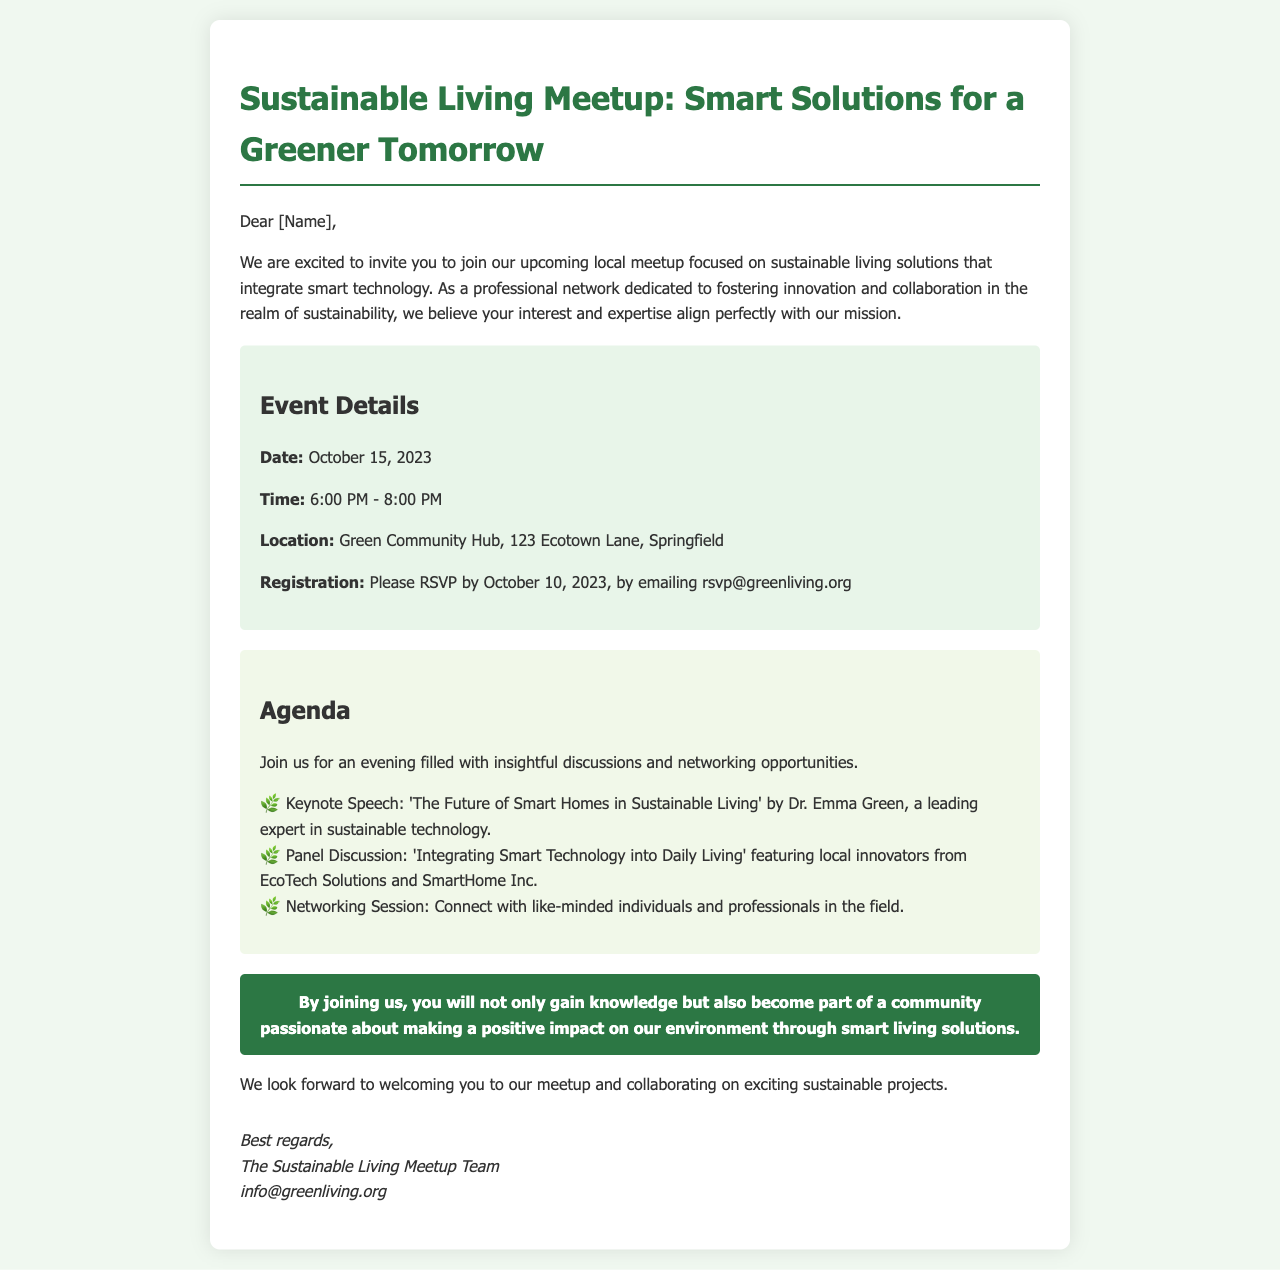What is the date of the event? The event date is explicitly stated in the document under "Event Details."
Answer: October 15, 2023 What time does the meetup start? The starting time is mentioned in the "Event Details" section of the document.
Answer: 6:00 PM Where is the event located? The location of the meetup is provided in the "Event Details" section.
Answer: Green Community Hub, 123 Ecotown Lane, Springfield Who is the keynote speaker? The document specifies the keynote speaker in the agenda section.
Answer: Dr. Emma Green What topic will the keynote speech cover? The topic of the keynote speech is included in the agenda.
Answer: The Future of Smart Homes in Sustainable Living When is the RSVP deadline? The RSVP deadline is mentioned in the "Event Details" section.
Answer: October 10, 2023 What is the purpose of the networking session? The purpose of the networking session is described in the agenda section.
Answer: Connect with like-minded individuals and professionals What type of organization is the meetup affiliated with? The type of organization is indicated at the beginning of the letter.
Answer: Professional network How can one RSVP for the event? The method for RSVPing is clearly outlined in the "Event Details" section.
Answer: By emailing rsvp@greenliving.org 